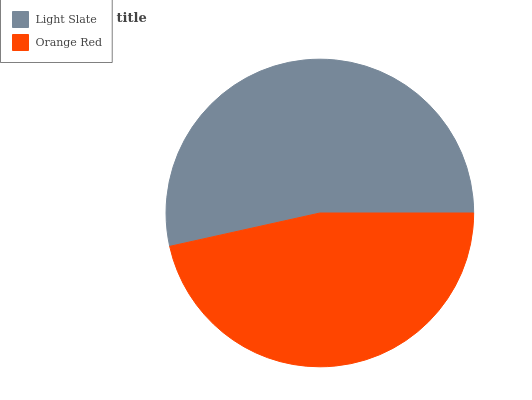Is Orange Red the minimum?
Answer yes or no. Yes. Is Light Slate the maximum?
Answer yes or no. Yes. Is Orange Red the maximum?
Answer yes or no. No. Is Light Slate greater than Orange Red?
Answer yes or no. Yes. Is Orange Red less than Light Slate?
Answer yes or no. Yes. Is Orange Red greater than Light Slate?
Answer yes or no. No. Is Light Slate less than Orange Red?
Answer yes or no. No. Is Light Slate the high median?
Answer yes or no. Yes. Is Orange Red the low median?
Answer yes or no. Yes. Is Orange Red the high median?
Answer yes or no. No. Is Light Slate the low median?
Answer yes or no. No. 